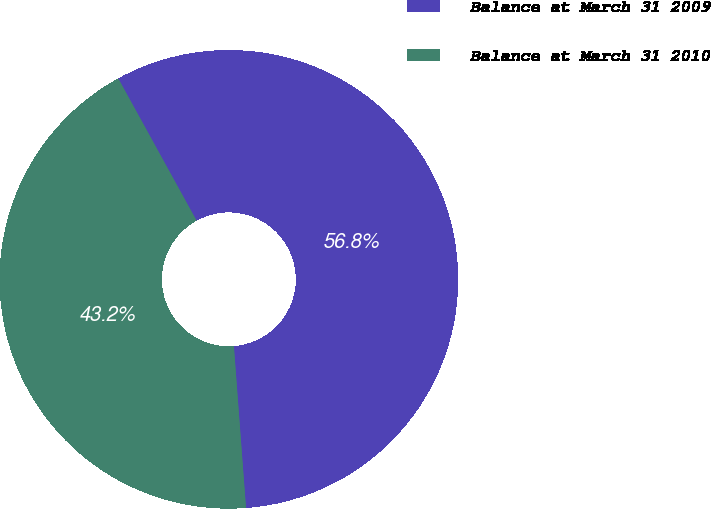<chart> <loc_0><loc_0><loc_500><loc_500><pie_chart><fcel>Balance at March 31 2009<fcel>Balance at March 31 2010<nl><fcel>56.82%<fcel>43.18%<nl></chart> 